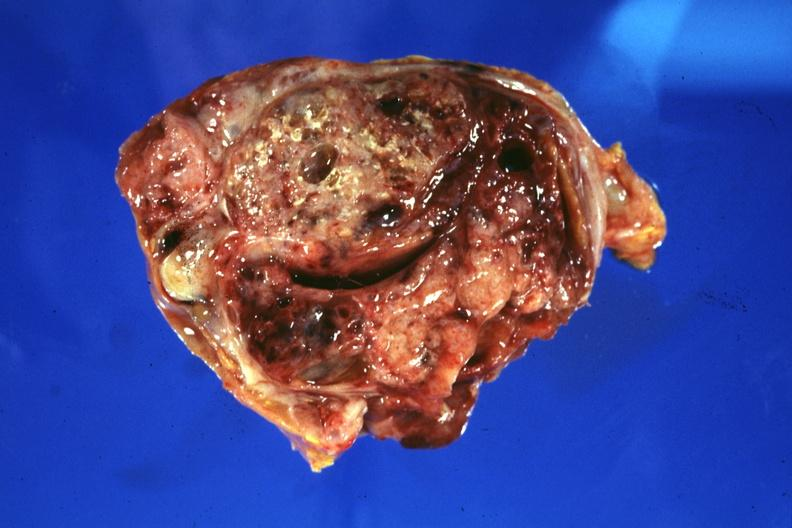what is present?
Answer the question using a single word or phrase. Sacrococcygeal teratoma 